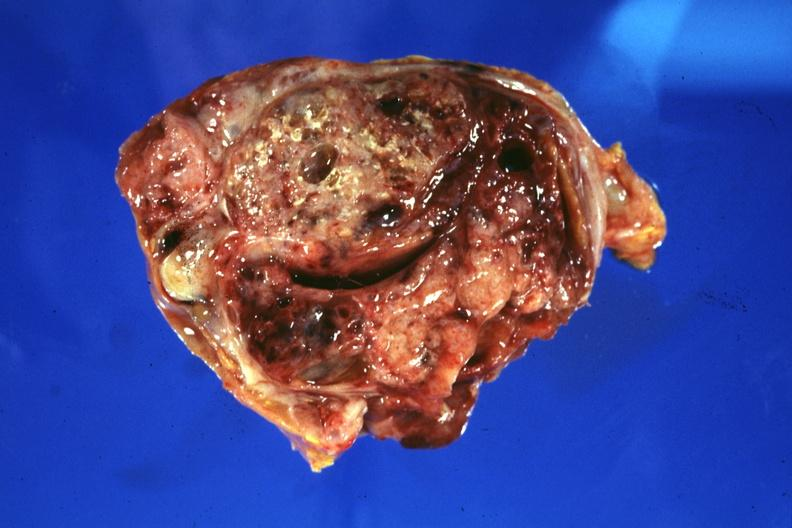what is present?
Answer the question using a single word or phrase. Sacrococcygeal teratoma 